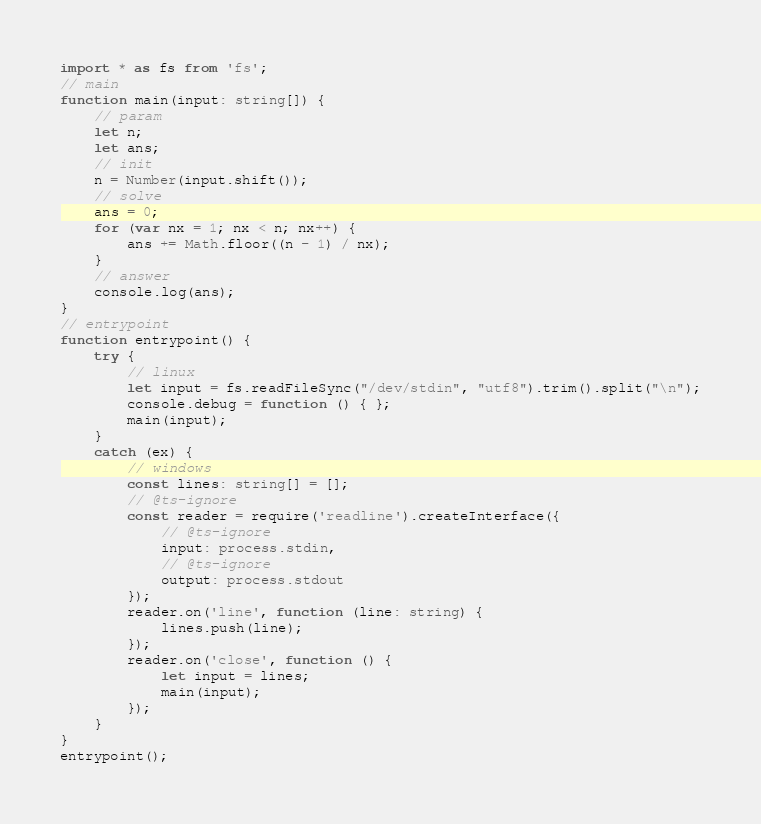<code> <loc_0><loc_0><loc_500><loc_500><_TypeScript_>import * as fs from 'fs';
// main
function main(input: string[]) {
    // param
    let n;
    let ans;
    // init
    n = Number(input.shift());
    // solve
    ans = 0;
    for (var nx = 1; nx < n; nx++) {
        ans += Math.floor((n - 1) / nx);
    }
    // answer
    console.log(ans);
}
// entrypoint
function entrypoint() {
    try {
        // linux
        let input = fs.readFileSync("/dev/stdin", "utf8").trim().split("\n");
        console.debug = function () { };
        main(input);
    }
    catch (ex) {
        // windows
        const lines: string[] = [];
        // @ts-ignore
        const reader = require('readline').createInterface({
            // @ts-ignore
            input: process.stdin,
            // @ts-ignore
            output: process.stdout
        });
        reader.on('line', function (line: string) {
            lines.push(line);
        });
        reader.on('close', function () {
            let input = lines;
            main(input);
        });
    }
}
entrypoint();
</code> 